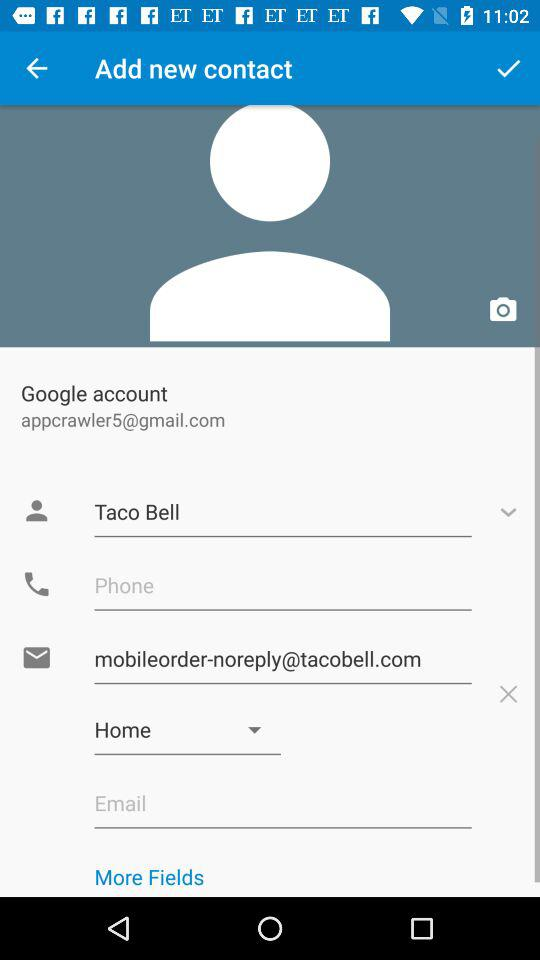What Gmail address is used? The used Gmail address is appcrawler5@gmail.com. 